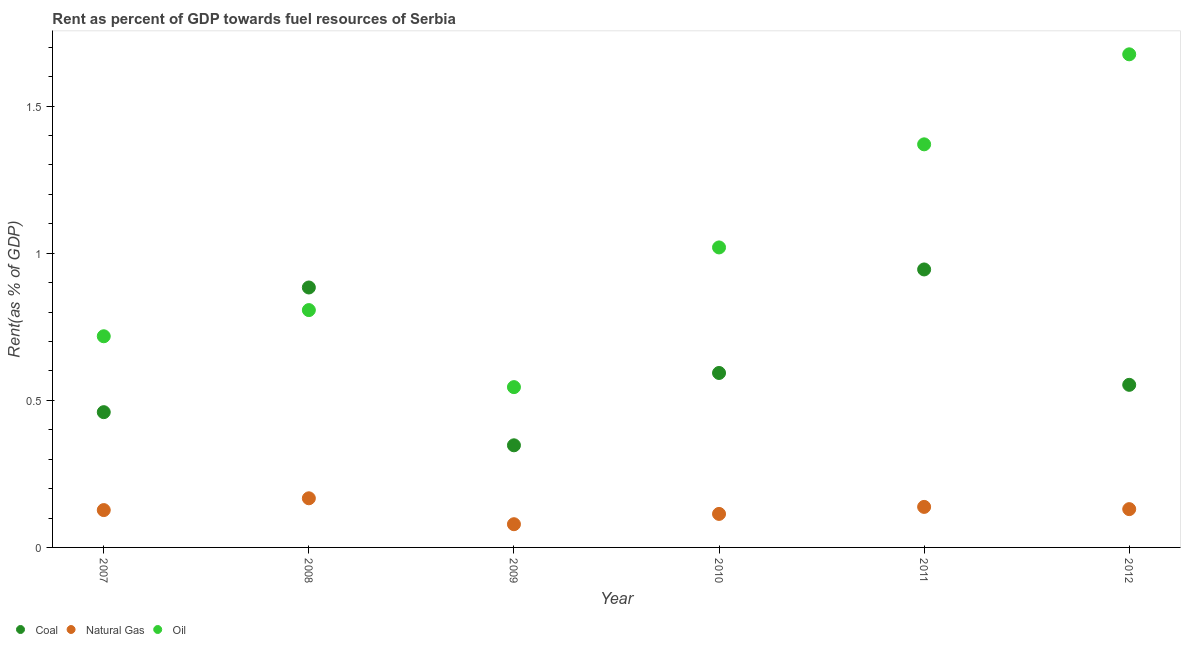How many different coloured dotlines are there?
Make the answer very short. 3. What is the rent towards coal in 2011?
Keep it short and to the point. 0.94. Across all years, what is the maximum rent towards oil?
Keep it short and to the point. 1.68. Across all years, what is the minimum rent towards coal?
Your response must be concise. 0.35. In which year was the rent towards coal maximum?
Provide a succinct answer. 2011. What is the total rent towards coal in the graph?
Make the answer very short. 3.78. What is the difference between the rent towards oil in 2007 and that in 2010?
Your answer should be very brief. -0.3. What is the difference between the rent towards oil in 2011 and the rent towards natural gas in 2012?
Your answer should be very brief. 1.24. What is the average rent towards natural gas per year?
Give a very brief answer. 0.13. In the year 2011, what is the difference between the rent towards coal and rent towards oil?
Offer a very short reply. -0.43. In how many years, is the rent towards natural gas greater than 0.2 %?
Provide a short and direct response. 0. What is the ratio of the rent towards coal in 2007 to that in 2011?
Provide a succinct answer. 0.49. Is the difference between the rent towards oil in 2010 and 2012 greater than the difference between the rent towards natural gas in 2010 and 2012?
Keep it short and to the point. No. What is the difference between the highest and the second highest rent towards natural gas?
Provide a succinct answer. 0.03. What is the difference between the highest and the lowest rent towards natural gas?
Provide a succinct answer. 0.09. How many years are there in the graph?
Give a very brief answer. 6. Are the values on the major ticks of Y-axis written in scientific E-notation?
Keep it short and to the point. No. Does the graph contain grids?
Offer a terse response. No. Where does the legend appear in the graph?
Provide a succinct answer. Bottom left. How are the legend labels stacked?
Give a very brief answer. Horizontal. What is the title of the graph?
Your answer should be compact. Rent as percent of GDP towards fuel resources of Serbia. What is the label or title of the X-axis?
Give a very brief answer. Year. What is the label or title of the Y-axis?
Keep it short and to the point. Rent(as % of GDP). What is the Rent(as % of GDP) of Coal in 2007?
Offer a terse response. 0.46. What is the Rent(as % of GDP) in Natural Gas in 2007?
Keep it short and to the point. 0.13. What is the Rent(as % of GDP) in Oil in 2007?
Your answer should be compact. 0.72. What is the Rent(as % of GDP) in Coal in 2008?
Your response must be concise. 0.88. What is the Rent(as % of GDP) of Natural Gas in 2008?
Offer a terse response. 0.17. What is the Rent(as % of GDP) in Oil in 2008?
Make the answer very short. 0.81. What is the Rent(as % of GDP) of Coal in 2009?
Your response must be concise. 0.35. What is the Rent(as % of GDP) of Natural Gas in 2009?
Ensure brevity in your answer.  0.08. What is the Rent(as % of GDP) in Oil in 2009?
Your answer should be very brief. 0.54. What is the Rent(as % of GDP) in Coal in 2010?
Give a very brief answer. 0.59. What is the Rent(as % of GDP) of Natural Gas in 2010?
Your answer should be compact. 0.11. What is the Rent(as % of GDP) of Oil in 2010?
Provide a succinct answer. 1.02. What is the Rent(as % of GDP) of Coal in 2011?
Your response must be concise. 0.94. What is the Rent(as % of GDP) of Natural Gas in 2011?
Provide a succinct answer. 0.14. What is the Rent(as % of GDP) in Oil in 2011?
Offer a terse response. 1.37. What is the Rent(as % of GDP) in Coal in 2012?
Your response must be concise. 0.55. What is the Rent(as % of GDP) in Natural Gas in 2012?
Your answer should be compact. 0.13. What is the Rent(as % of GDP) of Oil in 2012?
Your response must be concise. 1.68. Across all years, what is the maximum Rent(as % of GDP) in Coal?
Offer a terse response. 0.94. Across all years, what is the maximum Rent(as % of GDP) in Natural Gas?
Keep it short and to the point. 0.17. Across all years, what is the maximum Rent(as % of GDP) in Oil?
Your answer should be compact. 1.68. Across all years, what is the minimum Rent(as % of GDP) in Coal?
Make the answer very short. 0.35. Across all years, what is the minimum Rent(as % of GDP) in Natural Gas?
Provide a succinct answer. 0.08. Across all years, what is the minimum Rent(as % of GDP) of Oil?
Give a very brief answer. 0.54. What is the total Rent(as % of GDP) of Coal in the graph?
Give a very brief answer. 3.78. What is the total Rent(as % of GDP) in Natural Gas in the graph?
Your response must be concise. 0.75. What is the total Rent(as % of GDP) of Oil in the graph?
Your answer should be very brief. 6.14. What is the difference between the Rent(as % of GDP) in Coal in 2007 and that in 2008?
Your answer should be very brief. -0.42. What is the difference between the Rent(as % of GDP) of Natural Gas in 2007 and that in 2008?
Give a very brief answer. -0.04. What is the difference between the Rent(as % of GDP) in Oil in 2007 and that in 2008?
Provide a succinct answer. -0.09. What is the difference between the Rent(as % of GDP) in Coal in 2007 and that in 2009?
Give a very brief answer. 0.11. What is the difference between the Rent(as % of GDP) in Natural Gas in 2007 and that in 2009?
Offer a very short reply. 0.05. What is the difference between the Rent(as % of GDP) of Oil in 2007 and that in 2009?
Your response must be concise. 0.17. What is the difference between the Rent(as % of GDP) in Coal in 2007 and that in 2010?
Your answer should be compact. -0.13. What is the difference between the Rent(as % of GDP) of Natural Gas in 2007 and that in 2010?
Provide a short and direct response. 0.01. What is the difference between the Rent(as % of GDP) of Oil in 2007 and that in 2010?
Offer a terse response. -0.3. What is the difference between the Rent(as % of GDP) of Coal in 2007 and that in 2011?
Your response must be concise. -0.49. What is the difference between the Rent(as % of GDP) in Natural Gas in 2007 and that in 2011?
Ensure brevity in your answer.  -0.01. What is the difference between the Rent(as % of GDP) in Oil in 2007 and that in 2011?
Your answer should be compact. -0.65. What is the difference between the Rent(as % of GDP) of Coal in 2007 and that in 2012?
Provide a succinct answer. -0.09. What is the difference between the Rent(as % of GDP) in Natural Gas in 2007 and that in 2012?
Keep it short and to the point. -0. What is the difference between the Rent(as % of GDP) in Oil in 2007 and that in 2012?
Your answer should be very brief. -0.96. What is the difference between the Rent(as % of GDP) of Coal in 2008 and that in 2009?
Give a very brief answer. 0.54. What is the difference between the Rent(as % of GDP) of Natural Gas in 2008 and that in 2009?
Keep it short and to the point. 0.09. What is the difference between the Rent(as % of GDP) of Oil in 2008 and that in 2009?
Provide a short and direct response. 0.26. What is the difference between the Rent(as % of GDP) in Coal in 2008 and that in 2010?
Offer a terse response. 0.29. What is the difference between the Rent(as % of GDP) in Natural Gas in 2008 and that in 2010?
Your answer should be compact. 0.05. What is the difference between the Rent(as % of GDP) of Oil in 2008 and that in 2010?
Provide a short and direct response. -0.21. What is the difference between the Rent(as % of GDP) of Coal in 2008 and that in 2011?
Your answer should be very brief. -0.06. What is the difference between the Rent(as % of GDP) of Natural Gas in 2008 and that in 2011?
Offer a very short reply. 0.03. What is the difference between the Rent(as % of GDP) of Oil in 2008 and that in 2011?
Offer a terse response. -0.56. What is the difference between the Rent(as % of GDP) of Coal in 2008 and that in 2012?
Make the answer very short. 0.33. What is the difference between the Rent(as % of GDP) of Natural Gas in 2008 and that in 2012?
Give a very brief answer. 0.04. What is the difference between the Rent(as % of GDP) in Oil in 2008 and that in 2012?
Keep it short and to the point. -0.87. What is the difference between the Rent(as % of GDP) of Coal in 2009 and that in 2010?
Ensure brevity in your answer.  -0.25. What is the difference between the Rent(as % of GDP) of Natural Gas in 2009 and that in 2010?
Ensure brevity in your answer.  -0.04. What is the difference between the Rent(as % of GDP) in Oil in 2009 and that in 2010?
Make the answer very short. -0.47. What is the difference between the Rent(as % of GDP) in Coal in 2009 and that in 2011?
Your answer should be compact. -0.6. What is the difference between the Rent(as % of GDP) of Natural Gas in 2009 and that in 2011?
Your answer should be compact. -0.06. What is the difference between the Rent(as % of GDP) of Oil in 2009 and that in 2011?
Provide a short and direct response. -0.83. What is the difference between the Rent(as % of GDP) in Coal in 2009 and that in 2012?
Give a very brief answer. -0.21. What is the difference between the Rent(as % of GDP) of Natural Gas in 2009 and that in 2012?
Provide a short and direct response. -0.05. What is the difference between the Rent(as % of GDP) of Oil in 2009 and that in 2012?
Your answer should be compact. -1.13. What is the difference between the Rent(as % of GDP) in Coal in 2010 and that in 2011?
Offer a very short reply. -0.35. What is the difference between the Rent(as % of GDP) in Natural Gas in 2010 and that in 2011?
Give a very brief answer. -0.02. What is the difference between the Rent(as % of GDP) in Oil in 2010 and that in 2011?
Provide a succinct answer. -0.35. What is the difference between the Rent(as % of GDP) in Coal in 2010 and that in 2012?
Ensure brevity in your answer.  0.04. What is the difference between the Rent(as % of GDP) of Natural Gas in 2010 and that in 2012?
Offer a terse response. -0.02. What is the difference between the Rent(as % of GDP) of Oil in 2010 and that in 2012?
Your response must be concise. -0.66. What is the difference between the Rent(as % of GDP) of Coal in 2011 and that in 2012?
Provide a succinct answer. 0.39. What is the difference between the Rent(as % of GDP) in Natural Gas in 2011 and that in 2012?
Provide a succinct answer. 0.01. What is the difference between the Rent(as % of GDP) in Oil in 2011 and that in 2012?
Make the answer very short. -0.31. What is the difference between the Rent(as % of GDP) in Coal in 2007 and the Rent(as % of GDP) in Natural Gas in 2008?
Offer a very short reply. 0.29. What is the difference between the Rent(as % of GDP) in Coal in 2007 and the Rent(as % of GDP) in Oil in 2008?
Your answer should be very brief. -0.35. What is the difference between the Rent(as % of GDP) in Natural Gas in 2007 and the Rent(as % of GDP) in Oil in 2008?
Provide a short and direct response. -0.68. What is the difference between the Rent(as % of GDP) of Coal in 2007 and the Rent(as % of GDP) of Natural Gas in 2009?
Provide a succinct answer. 0.38. What is the difference between the Rent(as % of GDP) in Coal in 2007 and the Rent(as % of GDP) in Oil in 2009?
Provide a short and direct response. -0.09. What is the difference between the Rent(as % of GDP) of Natural Gas in 2007 and the Rent(as % of GDP) of Oil in 2009?
Make the answer very short. -0.42. What is the difference between the Rent(as % of GDP) in Coal in 2007 and the Rent(as % of GDP) in Natural Gas in 2010?
Give a very brief answer. 0.35. What is the difference between the Rent(as % of GDP) of Coal in 2007 and the Rent(as % of GDP) of Oil in 2010?
Make the answer very short. -0.56. What is the difference between the Rent(as % of GDP) in Natural Gas in 2007 and the Rent(as % of GDP) in Oil in 2010?
Make the answer very short. -0.89. What is the difference between the Rent(as % of GDP) in Coal in 2007 and the Rent(as % of GDP) in Natural Gas in 2011?
Ensure brevity in your answer.  0.32. What is the difference between the Rent(as % of GDP) in Coal in 2007 and the Rent(as % of GDP) in Oil in 2011?
Provide a succinct answer. -0.91. What is the difference between the Rent(as % of GDP) in Natural Gas in 2007 and the Rent(as % of GDP) in Oil in 2011?
Make the answer very short. -1.24. What is the difference between the Rent(as % of GDP) in Coal in 2007 and the Rent(as % of GDP) in Natural Gas in 2012?
Keep it short and to the point. 0.33. What is the difference between the Rent(as % of GDP) in Coal in 2007 and the Rent(as % of GDP) in Oil in 2012?
Your answer should be very brief. -1.22. What is the difference between the Rent(as % of GDP) in Natural Gas in 2007 and the Rent(as % of GDP) in Oil in 2012?
Make the answer very short. -1.55. What is the difference between the Rent(as % of GDP) of Coal in 2008 and the Rent(as % of GDP) of Natural Gas in 2009?
Ensure brevity in your answer.  0.8. What is the difference between the Rent(as % of GDP) of Coal in 2008 and the Rent(as % of GDP) of Oil in 2009?
Your answer should be very brief. 0.34. What is the difference between the Rent(as % of GDP) of Natural Gas in 2008 and the Rent(as % of GDP) of Oil in 2009?
Offer a terse response. -0.38. What is the difference between the Rent(as % of GDP) of Coal in 2008 and the Rent(as % of GDP) of Natural Gas in 2010?
Give a very brief answer. 0.77. What is the difference between the Rent(as % of GDP) of Coal in 2008 and the Rent(as % of GDP) of Oil in 2010?
Provide a short and direct response. -0.14. What is the difference between the Rent(as % of GDP) of Natural Gas in 2008 and the Rent(as % of GDP) of Oil in 2010?
Provide a short and direct response. -0.85. What is the difference between the Rent(as % of GDP) in Coal in 2008 and the Rent(as % of GDP) in Natural Gas in 2011?
Offer a terse response. 0.75. What is the difference between the Rent(as % of GDP) in Coal in 2008 and the Rent(as % of GDP) in Oil in 2011?
Your answer should be compact. -0.49. What is the difference between the Rent(as % of GDP) in Natural Gas in 2008 and the Rent(as % of GDP) in Oil in 2011?
Provide a short and direct response. -1.2. What is the difference between the Rent(as % of GDP) in Coal in 2008 and the Rent(as % of GDP) in Natural Gas in 2012?
Offer a very short reply. 0.75. What is the difference between the Rent(as % of GDP) in Coal in 2008 and the Rent(as % of GDP) in Oil in 2012?
Provide a short and direct response. -0.79. What is the difference between the Rent(as % of GDP) in Natural Gas in 2008 and the Rent(as % of GDP) in Oil in 2012?
Provide a short and direct response. -1.51. What is the difference between the Rent(as % of GDP) in Coal in 2009 and the Rent(as % of GDP) in Natural Gas in 2010?
Your answer should be compact. 0.23. What is the difference between the Rent(as % of GDP) of Coal in 2009 and the Rent(as % of GDP) of Oil in 2010?
Your answer should be compact. -0.67. What is the difference between the Rent(as % of GDP) in Natural Gas in 2009 and the Rent(as % of GDP) in Oil in 2010?
Keep it short and to the point. -0.94. What is the difference between the Rent(as % of GDP) in Coal in 2009 and the Rent(as % of GDP) in Natural Gas in 2011?
Provide a succinct answer. 0.21. What is the difference between the Rent(as % of GDP) of Coal in 2009 and the Rent(as % of GDP) of Oil in 2011?
Provide a succinct answer. -1.02. What is the difference between the Rent(as % of GDP) of Natural Gas in 2009 and the Rent(as % of GDP) of Oil in 2011?
Offer a terse response. -1.29. What is the difference between the Rent(as % of GDP) of Coal in 2009 and the Rent(as % of GDP) of Natural Gas in 2012?
Provide a succinct answer. 0.22. What is the difference between the Rent(as % of GDP) of Coal in 2009 and the Rent(as % of GDP) of Oil in 2012?
Your answer should be very brief. -1.33. What is the difference between the Rent(as % of GDP) of Natural Gas in 2009 and the Rent(as % of GDP) of Oil in 2012?
Ensure brevity in your answer.  -1.6. What is the difference between the Rent(as % of GDP) in Coal in 2010 and the Rent(as % of GDP) in Natural Gas in 2011?
Provide a succinct answer. 0.46. What is the difference between the Rent(as % of GDP) of Coal in 2010 and the Rent(as % of GDP) of Oil in 2011?
Your response must be concise. -0.78. What is the difference between the Rent(as % of GDP) in Natural Gas in 2010 and the Rent(as % of GDP) in Oil in 2011?
Provide a succinct answer. -1.26. What is the difference between the Rent(as % of GDP) of Coal in 2010 and the Rent(as % of GDP) of Natural Gas in 2012?
Provide a succinct answer. 0.46. What is the difference between the Rent(as % of GDP) of Coal in 2010 and the Rent(as % of GDP) of Oil in 2012?
Provide a succinct answer. -1.08. What is the difference between the Rent(as % of GDP) in Natural Gas in 2010 and the Rent(as % of GDP) in Oil in 2012?
Your answer should be very brief. -1.56. What is the difference between the Rent(as % of GDP) of Coal in 2011 and the Rent(as % of GDP) of Natural Gas in 2012?
Keep it short and to the point. 0.81. What is the difference between the Rent(as % of GDP) in Coal in 2011 and the Rent(as % of GDP) in Oil in 2012?
Your response must be concise. -0.73. What is the difference between the Rent(as % of GDP) in Natural Gas in 2011 and the Rent(as % of GDP) in Oil in 2012?
Provide a short and direct response. -1.54. What is the average Rent(as % of GDP) in Coal per year?
Give a very brief answer. 0.63. What is the average Rent(as % of GDP) in Natural Gas per year?
Your answer should be compact. 0.13. What is the average Rent(as % of GDP) of Oil per year?
Keep it short and to the point. 1.02. In the year 2007, what is the difference between the Rent(as % of GDP) in Coal and Rent(as % of GDP) in Natural Gas?
Give a very brief answer. 0.33. In the year 2007, what is the difference between the Rent(as % of GDP) in Coal and Rent(as % of GDP) in Oil?
Provide a short and direct response. -0.26. In the year 2007, what is the difference between the Rent(as % of GDP) in Natural Gas and Rent(as % of GDP) in Oil?
Give a very brief answer. -0.59. In the year 2008, what is the difference between the Rent(as % of GDP) of Coal and Rent(as % of GDP) of Natural Gas?
Give a very brief answer. 0.72. In the year 2008, what is the difference between the Rent(as % of GDP) in Coal and Rent(as % of GDP) in Oil?
Your response must be concise. 0.08. In the year 2008, what is the difference between the Rent(as % of GDP) in Natural Gas and Rent(as % of GDP) in Oil?
Offer a terse response. -0.64. In the year 2009, what is the difference between the Rent(as % of GDP) in Coal and Rent(as % of GDP) in Natural Gas?
Your answer should be compact. 0.27. In the year 2009, what is the difference between the Rent(as % of GDP) of Coal and Rent(as % of GDP) of Oil?
Offer a very short reply. -0.2. In the year 2009, what is the difference between the Rent(as % of GDP) in Natural Gas and Rent(as % of GDP) in Oil?
Ensure brevity in your answer.  -0.47. In the year 2010, what is the difference between the Rent(as % of GDP) in Coal and Rent(as % of GDP) in Natural Gas?
Your answer should be very brief. 0.48. In the year 2010, what is the difference between the Rent(as % of GDP) of Coal and Rent(as % of GDP) of Oil?
Provide a succinct answer. -0.43. In the year 2010, what is the difference between the Rent(as % of GDP) of Natural Gas and Rent(as % of GDP) of Oil?
Give a very brief answer. -0.91. In the year 2011, what is the difference between the Rent(as % of GDP) in Coal and Rent(as % of GDP) in Natural Gas?
Provide a short and direct response. 0.81. In the year 2011, what is the difference between the Rent(as % of GDP) in Coal and Rent(as % of GDP) in Oil?
Your answer should be compact. -0.43. In the year 2011, what is the difference between the Rent(as % of GDP) in Natural Gas and Rent(as % of GDP) in Oil?
Provide a succinct answer. -1.23. In the year 2012, what is the difference between the Rent(as % of GDP) of Coal and Rent(as % of GDP) of Natural Gas?
Your answer should be very brief. 0.42. In the year 2012, what is the difference between the Rent(as % of GDP) of Coal and Rent(as % of GDP) of Oil?
Ensure brevity in your answer.  -1.12. In the year 2012, what is the difference between the Rent(as % of GDP) of Natural Gas and Rent(as % of GDP) of Oil?
Keep it short and to the point. -1.55. What is the ratio of the Rent(as % of GDP) in Coal in 2007 to that in 2008?
Keep it short and to the point. 0.52. What is the ratio of the Rent(as % of GDP) in Natural Gas in 2007 to that in 2008?
Offer a terse response. 0.76. What is the ratio of the Rent(as % of GDP) of Oil in 2007 to that in 2008?
Offer a terse response. 0.89. What is the ratio of the Rent(as % of GDP) of Coal in 2007 to that in 2009?
Your response must be concise. 1.32. What is the ratio of the Rent(as % of GDP) of Natural Gas in 2007 to that in 2009?
Your response must be concise. 1.61. What is the ratio of the Rent(as % of GDP) in Oil in 2007 to that in 2009?
Ensure brevity in your answer.  1.32. What is the ratio of the Rent(as % of GDP) in Coal in 2007 to that in 2010?
Offer a very short reply. 0.78. What is the ratio of the Rent(as % of GDP) of Natural Gas in 2007 to that in 2010?
Ensure brevity in your answer.  1.11. What is the ratio of the Rent(as % of GDP) of Oil in 2007 to that in 2010?
Keep it short and to the point. 0.7. What is the ratio of the Rent(as % of GDP) in Coal in 2007 to that in 2011?
Your answer should be very brief. 0.49. What is the ratio of the Rent(as % of GDP) in Natural Gas in 2007 to that in 2011?
Offer a terse response. 0.92. What is the ratio of the Rent(as % of GDP) in Oil in 2007 to that in 2011?
Your answer should be very brief. 0.52. What is the ratio of the Rent(as % of GDP) of Coal in 2007 to that in 2012?
Offer a very short reply. 0.83. What is the ratio of the Rent(as % of GDP) in Oil in 2007 to that in 2012?
Offer a very short reply. 0.43. What is the ratio of the Rent(as % of GDP) in Coal in 2008 to that in 2009?
Keep it short and to the point. 2.55. What is the ratio of the Rent(as % of GDP) of Natural Gas in 2008 to that in 2009?
Provide a short and direct response. 2.12. What is the ratio of the Rent(as % of GDP) of Oil in 2008 to that in 2009?
Your response must be concise. 1.48. What is the ratio of the Rent(as % of GDP) in Coal in 2008 to that in 2010?
Your answer should be compact. 1.49. What is the ratio of the Rent(as % of GDP) of Natural Gas in 2008 to that in 2010?
Your answer should be compact. 1.47. What is the ratio of the Rent(as % of GDP) in Oil in 2008 to that in 2010?
Offer a very short reply. 0.79. What is the ratio of the Rent(as % of GDP) of Coal in 2008 to that in 2011?
Keep it short and to the point. 0.94. What is the ratio of the Rent(as % of GDP) of Natural Gas in 2008 to that in 2011?
Give a very brief answer. 1.21. What is the ratio of the Rent(as % of GDP) of Oil in 2008 to that in 2011?
Make the answer very short. 0.59. What is the ratio of the Rent(as % of GDP) in Coal in 2008 to that in 2012?
Your answer should be compact. 1.6. What is the ratio of the Rent(as % of GDP) in Natural Gas in 2008 to that in 2012?
Provide a succinct answer. 1.28. What is the ratio of the Rent(as % of GDP) of Oil in 2008 to that in 2012?
Ensure brevity in your answer.  0.48. What is the ratio of the Rent(as % of GDP) in Coal in 2009 to that in 2010?
Your response must be concise. 0.59. What is the ratio of the Rent(as % of GDP) in Natural Gas in 2009 to that in 2010?
Make the answer very short. 0.69. What is the ratio of the Rent(as % of GDP) of Oil in 2009 to that in 2010?
Provide a short and direct response. 0.53. What is the ratio of the Rent(as % of GDP) in Coal in 2009 to that in 2011?
Provide a succinct answer. 0.37. What is the ratio of the Rent(as % of GDP) in Natural Gas in 2009 to that in 2011?
Your answer should be compact. 0.57. What is the ratio of the Rent(as % of GDP) in Oil in 2009 to that in 2011?
Ensure brevity in your answer.  0.4. What is the ratio of the Rent(as % of GDP) of Coal in 2009 to that in 2012?
Provide a succinct answer. 0.63. What is the ratio of the Rent(as % of GDP) in Natural Gas in 2009 to that in 2012?
Your answer should be compact. 0.61. What is the ratio of the Rent(as % of GDP) of Oil in 2009 to that in 2012?
Your response must be concise. 0.33. What is the ratio of the Rent(as % of GDP) of Coal in 2010 to that in 2011?
Your response must be concise. 0.63. What is the ratio of the Rent(as % of GDP) in Natural Gas in 2010 to that in 2011?
Ensure brevity in your answer.  0.83. What is the ratio of the Rent(as % of GDP) of Oil in 2010 to that in 2011?
Your response must be concise. 0.74. What is the ratio of the Rent(as % of GDP) of Coal in 2010 to that in 2012?
Make the answer very short. 1.07. What is the ratio of the Rent(as % of GDP) in Natural Gas in 2010 to that in 2012?
Give a very brief answer. 0.88. What is the ratio of the Rent(as % of GDP) of Oil in 2010 to that in 2012?
Provide a short and direct response. 0.61. What is the ratio of the Rent(as % of GDP) of Coal in 2011 to that in 2012?
Offer a terse response. 1.71. What is the ratio of the Rent(as % of GDP) of Natural Gas in 2011 to that in 2012?
Offer a terse response. 1.06. What is the ratio of the Rent(as % of GDP) of Oil in 2011 to that in 2012?
Provide a succinct answer. 0.82. What is the difference between the highest and the second highest Rent(as % of GDP) of Coal?
Make the answer very short. 0.06. What is the difference between the highest and the second highest Rent(as % of GDP) of Natural Gas?
Your answer should be compact. 0.03. What is the difference between the highest and the second highest Rent(as % of GDP) in Oil?
Make the answer very short. 0.31. What is the difference between the highest and the lowest Rent(as % of GDP) in Coal?
Provide a succinct answer. 0.6. What is the difference between the highest and the lowest Rent(as % of GDP) of Natural Gas?
Your answer should be compact. 0.09. What is the difference between the highest and the lowest Rent(as % of GDP) of Oil?
Your answer should be compact. 1.13. 